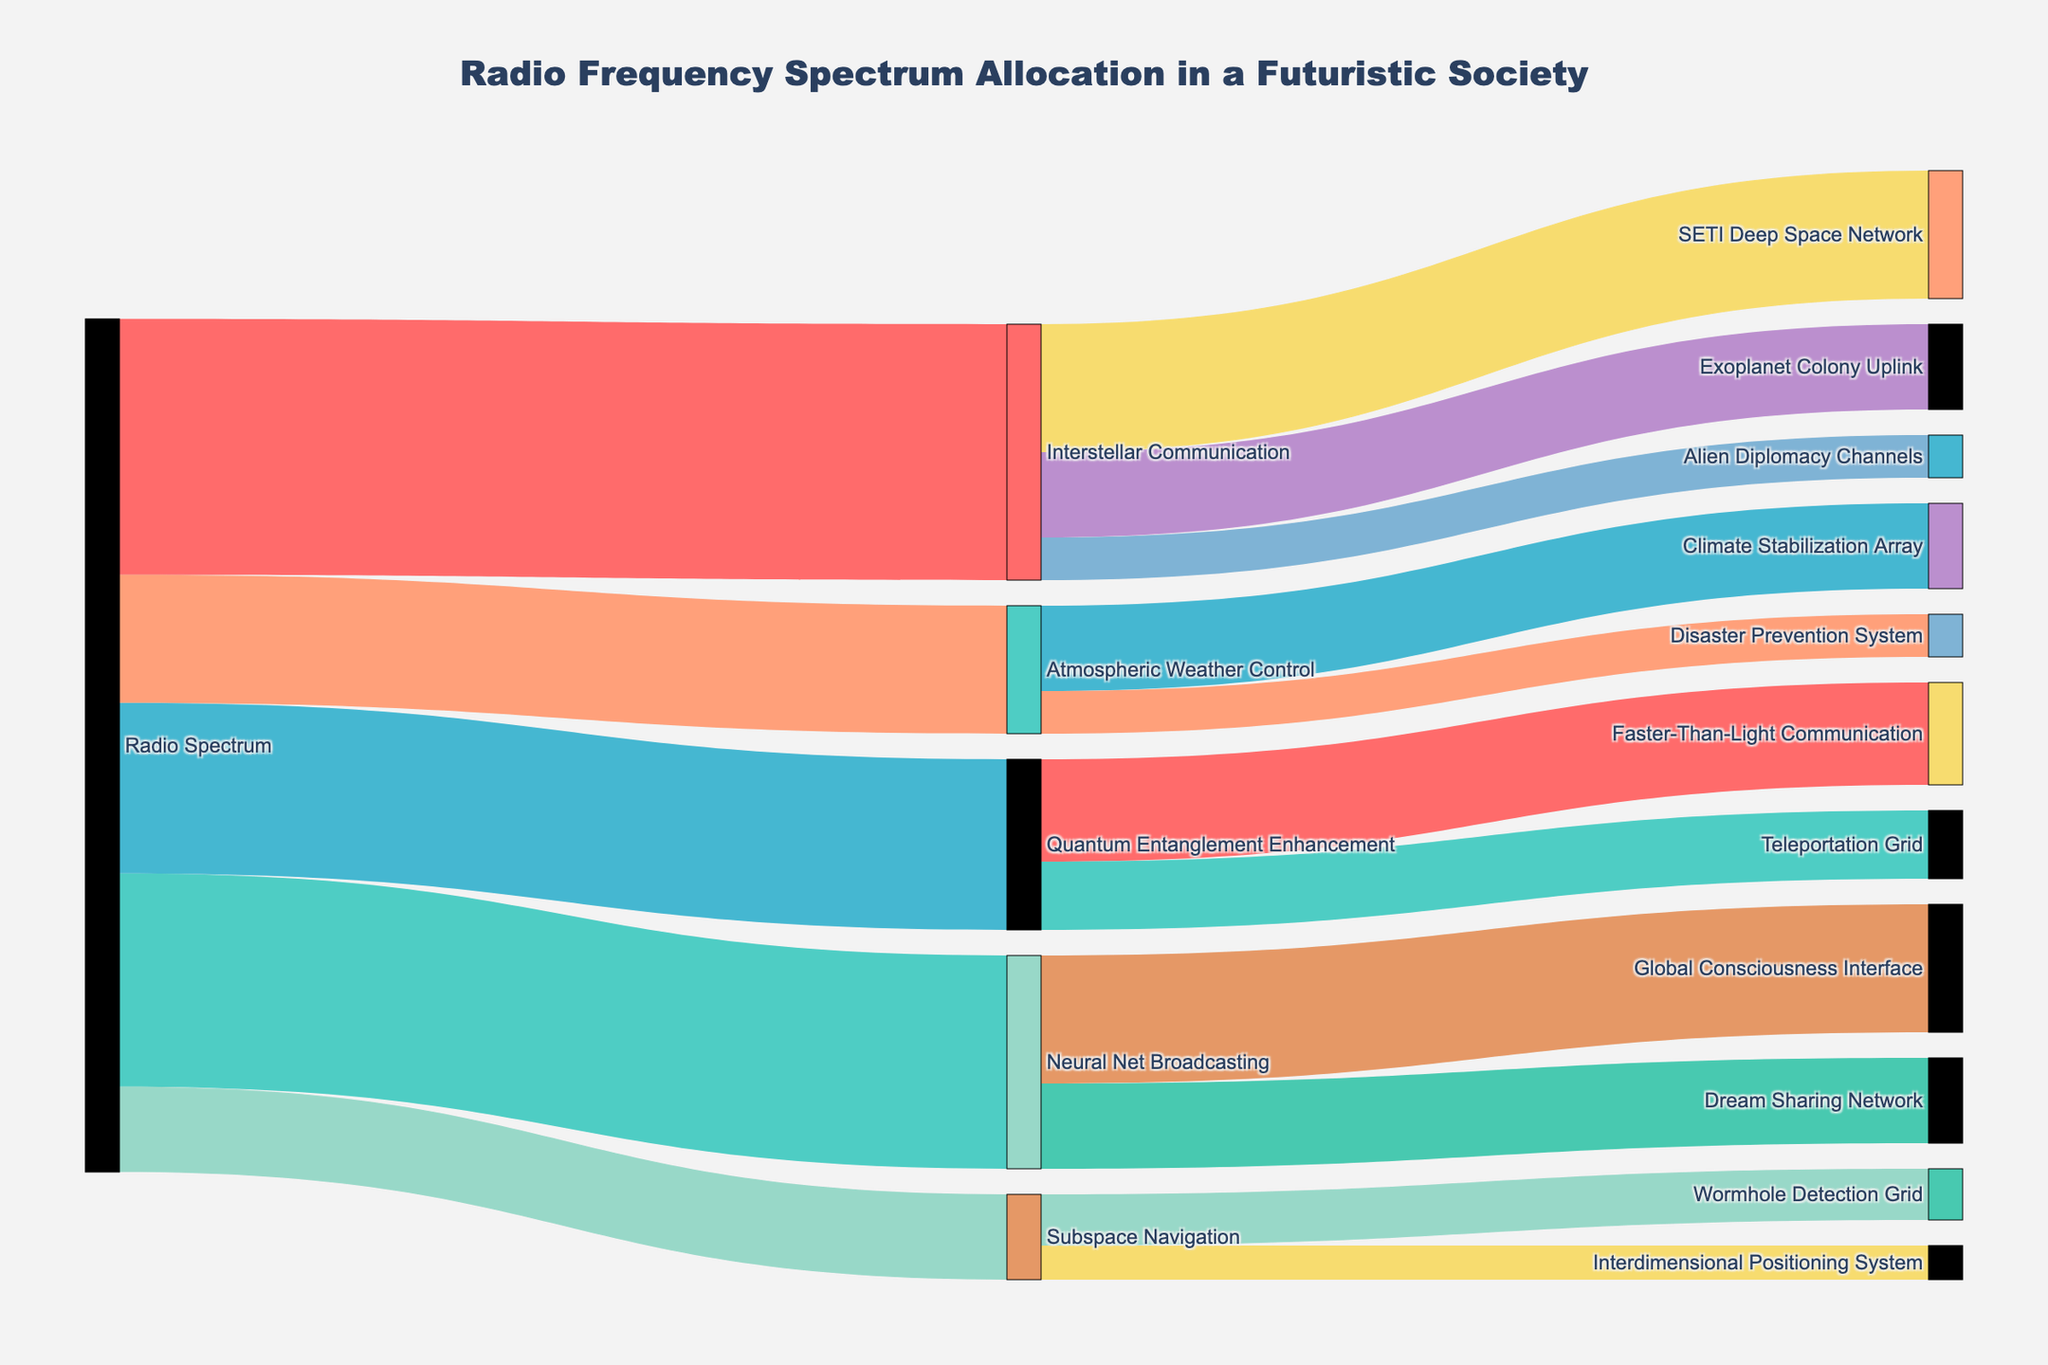What's the title of the figure? The title is usually prominently displayed at the top of the figure. Here, it reads "Radio Frequency Spectrum Allocation in a Futuristic Society" based on the layout setup.
Answer: Radio Frequency Spectrum Allocation in a Futuristic Society How much of the radio spectrum is allocated to Interstellar Communication? Each segment of the Sankey diagram indicates a certain value, and Interstellar Communication receives 30 units according to the provided data.
Answer: 30 What are the two largest allocations from the Radio Spectrum? By examining the widths of the segments, we can see that Interstellar Communication (30) and Neural Net Broadcasting (25) have the highest allocations.
Answer: Interstellar Communication and Neural Net Broadcasting What's the total value allocated from the Radio Spectrum? Sum all the values directly flowing from the Radio Spectrum: 30 + 25 + 20 + 15 + 10 = 100.
Answer: 100 How much of Neural Net Broadcasting is directed to the Dream Sharing Network? The link from Neural Net Broadcasting to Dream Sharing Network indicates the amount, which is specified in the data as 10 units.
Answer: 10 Which sub-allocation of Interstellar Communication receives the least amount, and how much is it? By examining the segments stemming from Interstellar Communication, Alien Diplomacy Channels receives the least with 5 units.
Answer: Alien Diplomacy Channels, 5 What is the total value used by Atmospheric Weather Control? Sum the values stemming from Atmospheric Weather Control: 10 (Climate Stabilization Array) + 5 (Disaster Prevention System) = 15.
Answer: 15 Compare the allocations to Quantum Entanglement Enhancement and Subspace Navigation. Which one is higher and by how much? Quantum Entanglement Enhancement has 20 units, and Subspace Navigation has 10 units. The difference is 20 - 10 = 10 units.
Answer: Quantum Entanglement Enhancement by 10 units Which category uses more of its allocation for Faster-Than-Light Communication, Interstellar Communication or Quantum Entanglement Enhancement? Only Quantum Entanglement Enhancement contributes to Faster-Than-Light Communication, with 12 units. Interstellar Communication does not contribute to it.
Answer: Quantum Entanglement Enhancement What percentage of the neural net broadcasting allocation is used by the Global Consciousness Interface? Neural Net Broadcasting has 25 units total, and Global Consciousness Interface uses 15 units. The percentage is (15 / 25) * 100% = 60%.
Answer: 60% 